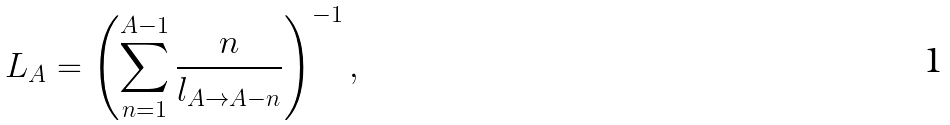Convert formula to latex. <formula><loc_0><loc_0><loc_500><loc_500>L _ { A } = \left ( \sum _ { n = 1 } ^ { A - 1 } \frac { n } { l _ { A \rightarrow A - n } } \right ) ^ { - 1 } ,</formula> 